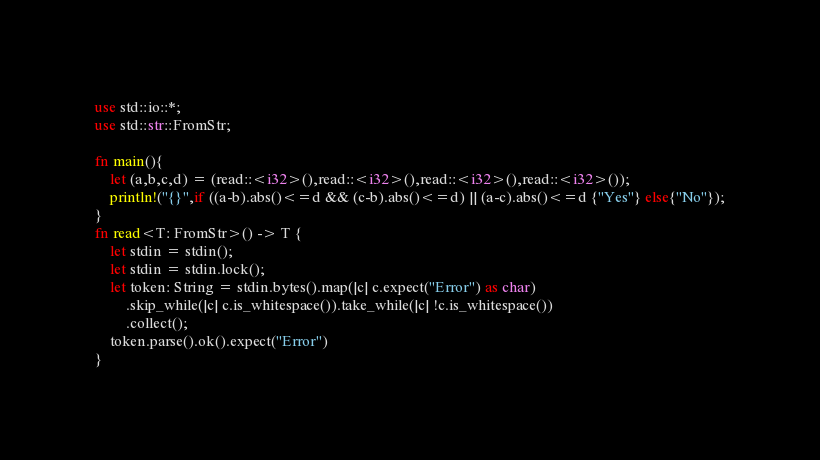<code> <loc_0><loc_0><loc_500><loc_500><_Rust_>use std::io::*;
use std::str::FromStr;

fn main(){
    let (a,b,c,d) = (read::<i32>(),read::<i32>(),read::<i32>(),read::<i32>());
    println!("{}",if ((a-b).abs()<=d && (c-b).abs()<=d) || (a-c).abs()<=d {"Yes"} else{"No"});
}
fn read<T: FromStr>() -> T {
    let stdin = stdin();
    let stdin = stdin.lock();
    let token: String = stdin.bytes().map(|c| c.expect("Error") as char) 
        .skip_while(|c| c.is_whitespace()).take_while(|c| !c.is_whitespace())
        .collect();
    token.parse().ok().expect("Error")
}</code> 